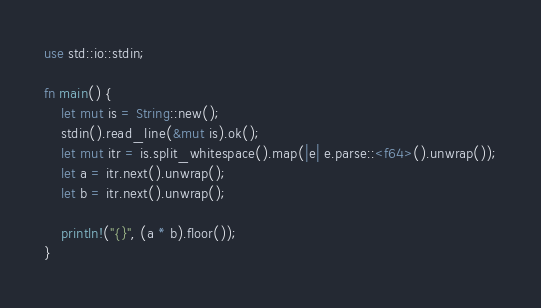<code> <loc_0><loc_0><loc_500><loc_500><_Rust_>use std::io::stdin;

fn main() {
    let mut is = String::new();
    stdin().read_line(&mut is).ok();
    let mut itr = is.split_whitespace().map(|e| e.parse::<f64>().unwrap());
    let a = itr.next().unwrap();
    let b = itr.next().unwrap();

    println!("{}", (a * b).floor());
}
</code> 